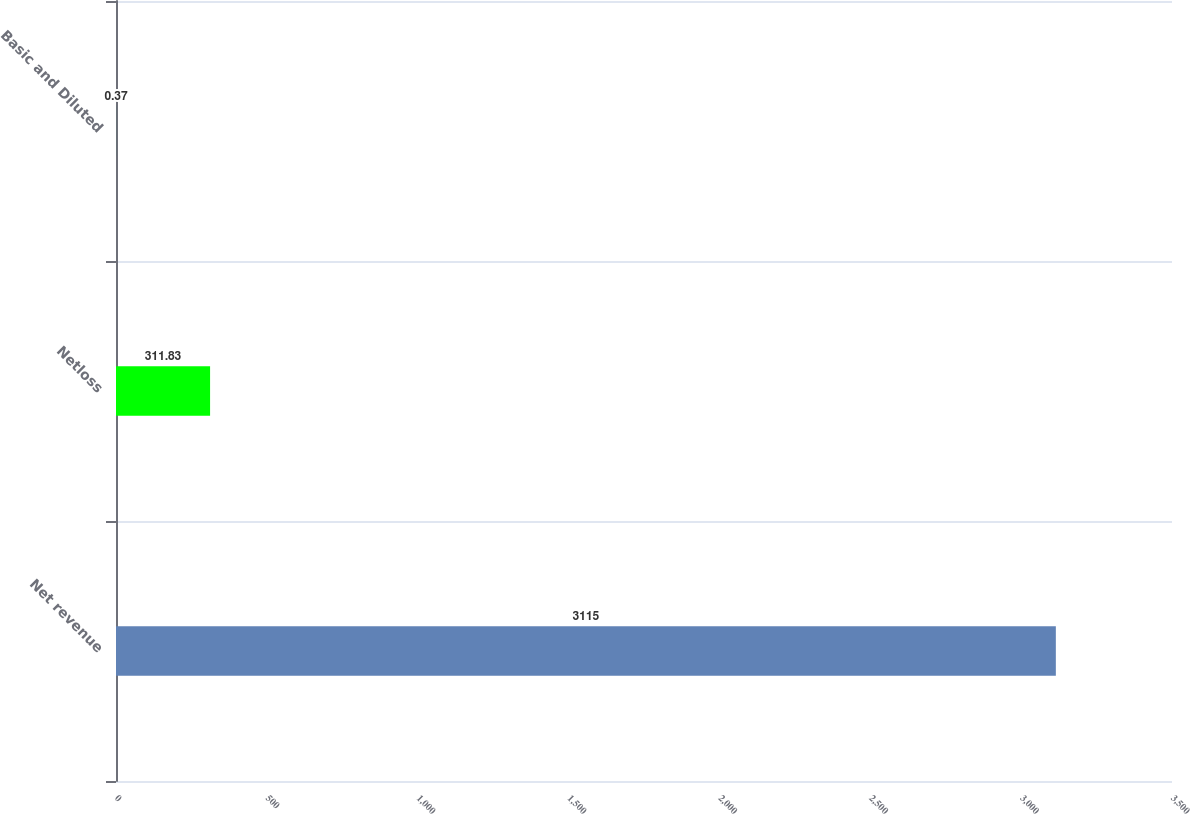Convert chart to OTSL. <chart><loc_0><loc_0><loc_500><loc_500><bar_chart><fcel>Net revenue<fcel>Netloss<fcel>Basic and Diluted<nl><fcel>3115<fcel>311.83<fcel>0.37<nl></chart> 